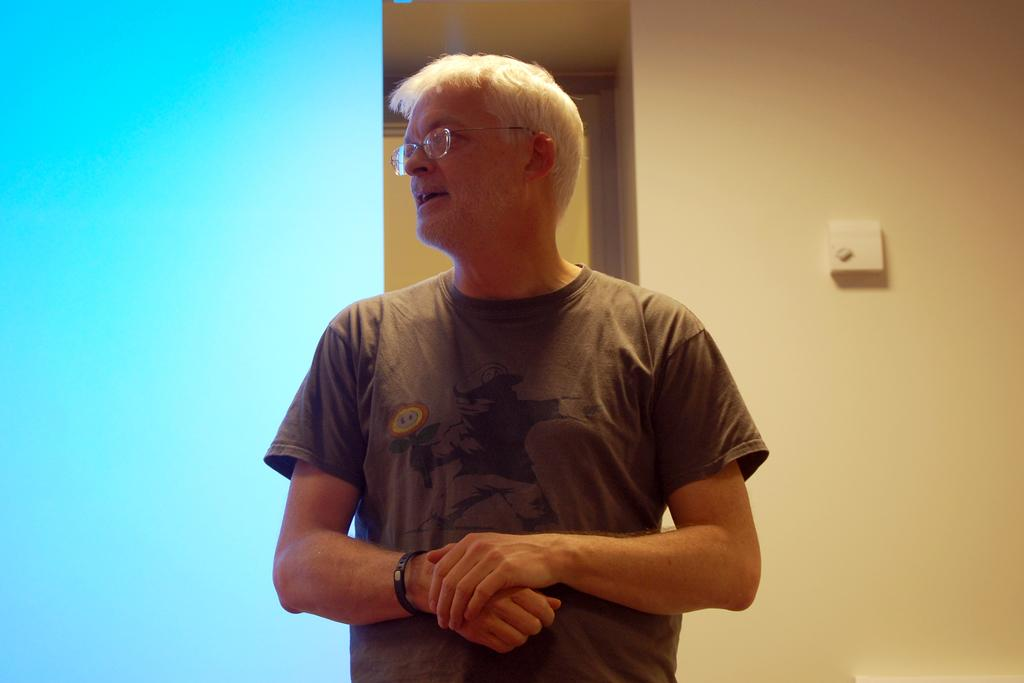Who is present in the image? There is a man in the image. What is behind the man in the image? There is a wall behind the man. What color or pattern is visible on the left side of the image? There is a blue background on the left side of the image. What type of sleet can be seen falling in the image? There is no sleet present in the image; it is a man standing in front of a wall with a blue background on the left side. 